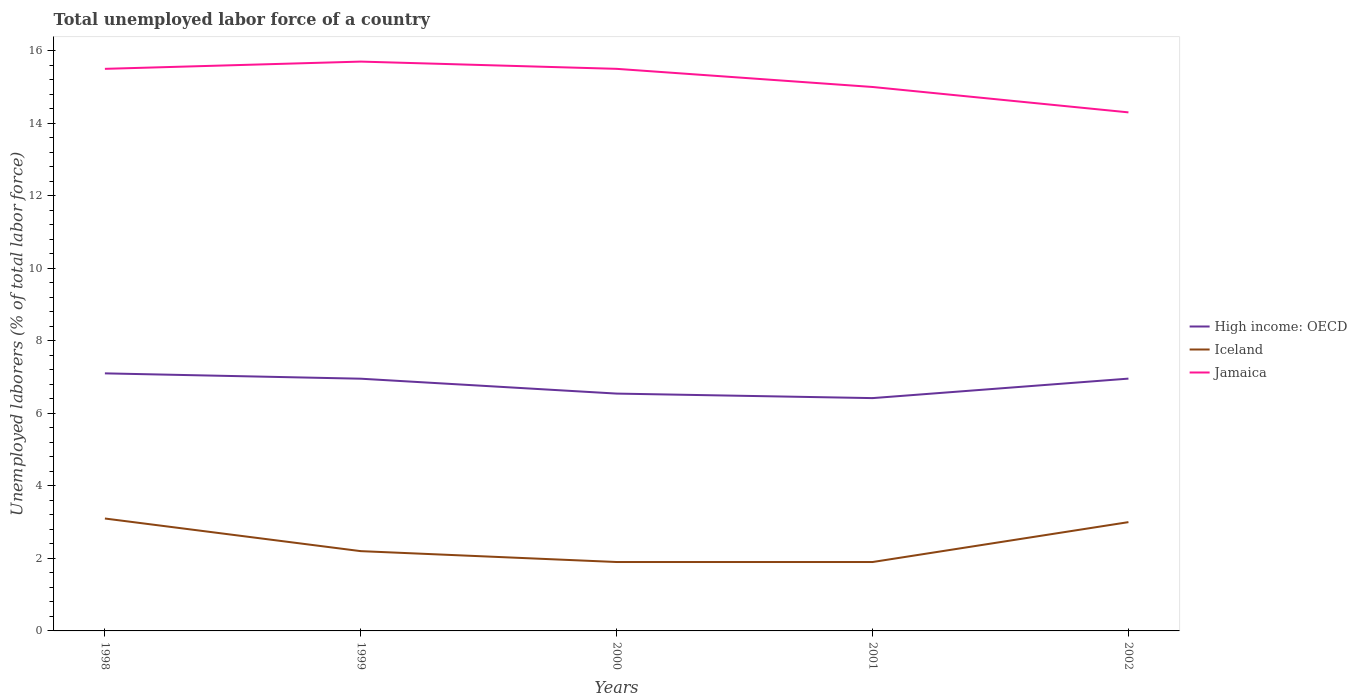Does the line corresponding to High income: OECD intersect with the line corresponding to Jamaica?
Provide a succinct answer. No. Across all years, what is the maximum total unemployed labor force in Iceland?
Give a very brief answer. 1.9. What is the total total unemployed labor force in High income: OECD in the graph?
Provide a succinct answer. -0. What is the difference between the highest and the second highest total unemployed labor force in Iceland?
Give a very brief answer. 1.2. How many lines are there?
Offer a very short reply. 3. What is the difference between two consecutive major ticks on the Y-axis?
Your answer should be compact. 2. Are the values on the major ticks of Y-axis written in scientific E-notation?
Your answer should be compact. No. Does the graph contain grids?
Provide a short and direct response. No. How many legend labels are there?
Give a very brief answer. 3. How are the legend labels stacked?
Offer a terse response. Vertical. What is the title of the graph?
Make the answer very short. Total unemployed labor force of a country. What is the label or title of the Y-axis?
Offer a very short reply. Unemployed laborers (% of total labor force). What is the Unemployed laborers (% of total labor force) in High income: OECD in 1998?
Make the answer very short. 7.1. What is the Unemployed laborers (% of total labor force) in Iceland in 1998?
Your answer should be very brief. 3.1. What is the Unemployed laborers (% of total labor force) of Jamaica in 1998?
Offer a terse response. 15.5. What is the Unemployed laborers (% of total labor force) of High income: OECD in 1999?
Keep it short and to the point. 6.96. What is the Unemployed laborers (% of total labor force) in Iceland in 1999?
Make the answer very short. 2.2. What is the Unemployed laborers (% of total labor force) in Jamaica in 1999?
Offer a terse response. 15.7. What is the Unemployed laborers (% of total labor force) of High income: OECD in 2000?
Your answer should be compact. 6.54. What is the Unemployed laborers (% of total labor force) in Iceland in 2000?
Make the answer very short. 1.9. What is the Unemployed laborers (% of total labor force) of High income: OECD in 2001?
Ensure brevity in your answer.  6.42. What is the Unemployed laborers (% of total labor force) in Iceland in 2001?
Make the answer very short. 1.9. What is the Unemployed laborers (% of total labor force) in Jamaica in 2001?
Keep it short and to the point. 15. What is the Unemployed laborers (% of total labor force) in High income: OECD in 2002?
Your answer should be compact. 6.96. What is the Unemployed laborers (% of total labor force) in Iceland in 2002?
Ensure brevity in your answer.  3. What is the Unemployed laborers (% of total labor force) in Jamaica in 2002?
Ensure brevity in your answer.  14.3. Across all years, what is the maximum Unemployed laborers (% of total labor force) of High income: OECD?
Offer a terse response. 7.1. Across all years, what is the maximum Unemployed laborers (% of total labor force) of Iceland?
Ensure brevity in your answer.  3.1. Across all years, what is the maximum Unemployed laborers (% of total labor force) in Jamaica?
Make the answer very short. 15.7. Across all years, what is the minimum Unemployed laborers (% of total labor force) in High income: OECD?
Keep it short and to the point. 6.42. Across all years, what is the minimum Unemployed laborers (% of total labor force) in Iceland?
Your answer should be very brief. 1.9. Across all years, what is the minimum Unemployed laborers (% of total labor force) in Jamaica?
Your answer should be compact. 14.3. What is the total Unemployed laborers (% of total labor force) of High income: OECD in the graph?
Keep it short and to the point. 33.98. What is the total Unemployed laborers (% of total labor force) in Iceland in the graph?
Offer a very short reply. 12.1. What is the total Unemployed laborers (% of total labor force) in Jamaica in the graph?
Your answer should be very brief. 76. What is the difference between the Unemployed laborers (% of total labor force) in High income: OECD in 1998 and that in 1999?
Your response must be concise. 0.15. What is the difference between the Unemployed laborers (% of total labor force) in Iceland in 1998 and that in 1999?
Your answer should be very brief. 0.9. What is the difference between the Unemployed laborers (% of total labor force) in Jamaica in 1998 and that in 1999?
Provide a succinct answer. -0.2. What is the difference between the Unemployed laborers (% of total labor force) of High income: OECD in 1998 and that in 2000?
Make the answer very short. 0.56. What is the difference between the Unemployed laborers (% of total labor force) in Jamaica in 1998 and that in 2000?
Give a very brief answer. 0. What is the difference between the Unemployed laborers (% of total labor force) in High income: OECD in 1998 and that in 2001?
Offer a terse response. 0.68. What is the difference between the Unemployed laborers (% of total labor force) in Iceland in 1998 and that in 2001?
Offer a terse response. 1.2. What is the difference between the Unemployed laborers (% of total labor force) of Jamaica in 1998 and that in 2001?
Give a very brief answer. 0.5. What is the difference between the Unemployed laborers (% of total labor force) of High income: OECD in 1998 and that in 2002?
Offer a terse response. 0.15. What is the difference between the Unemployed laborers (% of total labor force) in Iceland in 1998 and that in 2002?
Ensure brevity in your answer.  0.1. What is the difference between the Unemployed laborers (% of total labor force) in High income: OECD in 1999 and that in 2000?
Give a very brief answer. 0.41. What is the difference between the Unemployed laborers (% of total labor force) in High income: OECD in 1999 and that in 2001?
Make the answer very short. 0.54. What is the difference between the Unemployed laborers (% of total labor force) in Jamaica in 1999 and that in 2001?
Give a very brief answer. 0.7. What is the difference between the Unemployed laborers (% of total labor force) of High income: OECD in 1999 and that in 2002?
Provide a succinct answer. -0. What is the difference between the Unemployed laborers (% of total labor force) of Iceland in 1999 and that in 2002?
Provide a succinct answer. -0.8. What is the difference between the Unemployed laborers (% of total labor force) in Jamaica in 1999 and that in 2002?
Make the answer very short. 1.4. What is the difference between the Unemployed laborers (% of total labor force) of High income: OECD in 2000 and that in 2001?
Your answer should be very brief. 0.12. What is the difference between the Unemployed laborers (% of total labor force) in High income: OECD in 2000 and that in 2002?
Offer a terse response. -0.41. What is the difference between the Unemployed laborers (% of total labor force) of Iceland in 2000 and that in 2002?
Provide a succinct answer. -1.1. What is the difference between the Unemployed laborers (% of total labor force) of High income: OECD in 2001 and that in 2002?
Your answer should be compact. -0.54. What is the difference between the Unemployed laborers (% of total labor force) in Iceland in 2001 and that in 2002?
Your answer should be very brief. -1.1. What is the difference between the Unemployed laborers (% of total labor force) in Jamaica in 2001 and that in 2002?
Provide a succinct answer. 0.7. What is the difference between the Unemployed laborers (% of total labor force) of High income: OECD in 1998 and the Unemployed laborers (% of total labor force) of Iceland in 1999?
Ensure brevity in your answer.  4.9. What is the difference between the Unemployed laborers (% of total labor force) of High income: OECD in 1998 and the Unemployed laborers (% of total labor force) of Jamaica in 1999?
Offer a terse response. -8.6. What is the difference between the Unemployed laborers (% of total labor force) of Iceland in 1998 and the Unemployed laborers (% of total labor force) of Jamaica in 1999?
Your answer should be very brief. -12.6. What is the difference between the Unemployed laborers (% of total labor force) of High income: OECD in 1998 and the Unemployed laborers (% of total labor force) of Iceland in 2000?
Your answer should be compact. 5.2. What is the difference between the Unemployed laborers (% of total labor force) in High income: OECD in 1998 and the Unemployed laborers (% of total labor force) in Jamaica in 2000?
Make the answer very short. -8.4. What is the difference between the Unemployed laborers (% of total labor force) of Iceland in 1998 and the Unemployed laborers (% of total labor force) of Jamaica in 2000?
Give a very brief answer. -12.4. What is the difference between the Unemployed laborers (% of total labor force) in High income: OECD in 1998 and the Unemployed laborers (% of total labor force) in Iceland in 2001?
Provide a succinct answer. 5.2. What is the difference between the Unemployed laborers (% of total labor force) of High income: OECD in 1998 and the Unemployed laborers (% of total labor force) of Jamaica in 2001?
Ensure brevity in your answer.  -7.9. What is the difference between the Unemployed laborers (% of total labor force) of High income: OECD in 1998 and the Unemployed laborers (% of total labor force) of Iceland in 2002?
Your answer should be very brief. 4.1. What is the difference between the Unemployed laborers (% of total labor force) in High income: OECD in 1998 and the Unemployed laborers (% of total labor force) in Jamaica in 2002?
Your response must be concise. -7.2. What is the difference between the Unemployed laborers (% of total labor force) in High income: OECD in 1999 and the Unemployed laborers (% of total labor force) in Iceland in 2000?
Make the answer very short. 5.06. What is the difference between the Unemployed laborers (% of total labor force) of High income: OECD in 1999 and the Unemployed laborers (% of total labor force) of Jamaica in 2000?
Your answer should be very brief. -8.54. What is the difference between the Unemployed laborers (% of total labor force) in Iceland in 1999 and the Unemployed laborers (% of total labor force) in Jamaica in 2000?
Make the answer very short. -13.3. What is the difference between the Unemployed laborers (% of total labor force) of High income: OECD in 1999 and the Unemployed laborers (% of total labor force) of Iceland in 2001?
Offer a terse response. 5.06. What is the difference between the Unemployed laborers (% of total labor force) of High income: OECD in 1999 and the Unemployed laborers (% of total labor force) of Jamaica in 2001?
Your response must be concise. -8.04. What is the difference between the Unemployed laborers (% of total labor force) of High income: OECD in 1999 and the Unemployed laborers (% of total labor force) of Iceland in 2002?
Make the answer very short. 3.96. What is the difference between the Unemployed laborers (% of total labor force) of High income: OECD in 1999 and the Unemployed laborers (% of total labor force) of Jamaica in 2002?
Provide a short and direct response. -7.34. What is the difference between the Unemployed laborers (% of total labor force) of Iceland in 1999 and the Unemployed laborers (% of total labor force) of Jamaica in 2002?
Your answer should be very brief. -12.1. What is the difference between the Unemployed laborers (% of total labor force) in High income: OECD in 2000 and the Unemployed laborers (% of total labor force) in Iceland in 2001?
Your response must be concise. 4.64. What is the difference between the Unemployed laborers (% of total labor force) in High income: OECD in 2000 and the Unemployed laborers (% of total labor force) in Jamaica in 2001?
Offer a terse response. -8.46. What is the difference between the Unemployed laborers (% of total labor force) in Iceland in 2000 and the Unemployed laborers (% of total labor force) in Jamaica in 2001?
Ensure brevity in your answer.  -13.1. What is the difference between the Unemployed laborers (% of total labor force) of High income: OECD in 2000 and the Unemployed laborers (% of total labor force) of Iceland in 2002?
Your response must be concise. 3.54. What is the difference between the Unemployed laborers (% of total labor force) of High income: OECD in 2000 and the Unemployed laborers (% of total labor force) of Jamaica in 2002?
Make the answer very short. -7.76. What is the difference between the Unemployed laborers (% of total labor force) of High income: OECD in 2001 and the Unemployed laborers (% of total labor force) of Iceland in 2002?
Provide a short and direct response. 3.42. What is the difference between the Unemployed laborers (% of total labor force) in High income: OECD in 2001 and the Unemployed laborers (% of total labor force) in Jamaica in 2002?
Your answer should be compact. -7.88. What is the difference between the Unemployed laborers (% of total labor force) in Iceland in 2001 and the Unemployed laborers (% of total labor force) in Jamaica in 2002?
Give a very brief answer. -12.4. What is the average Unemployed laborers (% of total labor force) of High income: OECD per year?
Provide a succinct answer. 6.8. What is the average Unemployed laborers (% of total labor force) in Iceland per year?
Ensure brevity in your answer.  2.42. In the year 1998, what is the difference between the Unemployed laborers (% of total labor force) of High income: OECD and Unemployed laborers (% of total labor force) of Iceland?
Your answer should be compact. 4. In the year 1998, what is the difference between the Unemployed laborers (% of total labor force) in High income: OECD and Unemployed laborers (% of total labor force) in Jamaica?
Give a very brief answer. -8.4. In the year 1999, what is the difference between the Unemployed laborers (% of total labor force) in High income: OECD and Unemployed laborers (% of total labor force) in Iceland?
Your response must be concise. 4.76. In the year 1999, what is the difference between the Unemployed laborers (% of total labor force) of High income: OECD and Unemployed laborers (% of total labor force) of Jamaica?
Your response must be concise. -8.74. In the year 2000, what is the difference between the Unemployed laborers (% of total labor force) in High income: OECD and Unemployed laborers (% of total labor force) in Iceland?
Make the answer very short. 4.64. In the year 2000, what is the difference between the Unemployed laborers (% of total labor force) in High income: OECD and Unemployed laborers (% of total labor force) in Jamaica?
Provide a succinct answer. -8.96. In the year 2000, what is the difference between the Unemployed laborers (% of total labor force) in Iceland and Unemployed laborers (% of total labor force) in Jamaica?
Your answer should be compact. -13.6. In the year 2001, what is the difference between the Unemployed laborers (% of total labor force) of High income: OECD and Unemployed laborers (% of total labor force) of Iceland?
Your answer should be compact. 4.52. In the year 2001, what is the difference between the Unemployed laborers (% of total labor force) of High income: OECD and Unemployed laborers (% of total labor force) of Jamaica?
Provide a short and direct response. -8.58. In the year 2002, what is the difference between the Unemployed laborers (% of total labor force) of High income: OECD and Unemployed laborers (% of total labor force) of Iceland?
Offer a very short reply. 3.96. In the year 2002, what is the difference between the Unemployed laborers (% of total labor force) in High income: OECD and Unemployed laborers (% of total labor force) in Jamaica?
Your answer should be compact. -7.34. What is the ratio of the Unemployed laborers (% of total labor force) in High income: OECD in 1998 to that in 1999?
Provide a succinct answer. 1.02. What is the ratio of the Unemployed laborers (% of total labor force) of Iceland in 1998 to that in 1999?
Offer a very short reply. 1.41. What is the ratio of the Unemployed laborers (% of total labor force) in Jamaica in 1998 to that in 1999?
Make the answer very short. 0.99. What is the ratio of the Unemployed laborers (% of total labor force) of High income: OECD in 1998 to that in 2000?
Your answer should be very brief. 1.09. What is the ratio of the Unemployed laborers (% of total labor force) in Iceland in 1998 to that in 2000?
Ensure brevity in your answer.  1.63. What is the ratio of the Unemployed laborers (% of total labor force) in High income: OECD in 1998 to that in 2001?
Provide a short and direct response. 1.11. What is the ratio of the Unemployed laborers (% of total labor force) in Iceland in 1998 to that in 2001?
Give a very brief answer. 1.63. What is the ratio of the Unemployed laborers (% of total labor force) of Jamaica in 1998 to that in 2001?
Provide a succinct answer. 1.03. What is the ratio of the Unemployed laborers (% of total labor force) of High income: OECD in 1998 to that in 2002?
Your answer should be compact. 1.02. What is the ratio of the Unemployed laborers (% of total labor force) in Iceland in 1998 to that in 2002?
Make the answer very short. 1.03. What is the ratio of the Unemployed laborers (% of total labor force) of Jamaica in 1998 to that in 2002?
Your answer should be very brief. 1.08. What is the ratio of the Unemployed laborers (% of total labor force) of High income: OECD in 1999 to that in 2000?
Provide a succinct answer. 1.06. What is the ratio of the Unemployed laborers (% of total labor force) in Iceland in 1999 to that in 2000?
Offer a very short reply. 1.16. What is the ratio of the Unemployed laborers (% of total labor force) of Jamaica in 1999 to that in 2000?
Offer a terse response. 1.01. What is the ratio of the Unemployed laborers (% of total labor force) in High income: OECD in 1999 to that in 2001?
Provide a succinct answer. 1.08. What is the ratio of the Unemployed laborers (% of total labor force) in Iceland in 1999 to that in 2001?
Ensure brevity in your answer.  1.16. What is the ratio of the Unemployed laborers (% of total labor force) of Jamaica in 1999 to that in 2001?
Provide a short and direct response. 1.05. What is the ratio of the Unemployed laborers (% of total labor force) of High income: OECD in 1999 to that in 2002?
Ensure brevity in your answer.  1. What is the ratio of the Unemployed laborers (% of total labor force) in Iceland in 1999 to that in 2002?
Make the answer very short. 0.73. What is the ratio of the Unemployed laborers (% of total labor force) of Jamaica in 1999 to that in 2002?
Keep it short and to the point. 1.1. What is the ratio of the Unemployed laborers (% of total labor force) in High income: OECD in 2000 to that in 2001?
Provide a succinct answer. 1.02. What is the ratio of the Unemployed laborers (% of total labor force) in Iceland in 2000 to that in 2001?
Make the answer very short. 1. What is the ratio of the Unemployed laborers (% of total labor force) in High income: OECD in 2000 to that in 2002?
Offer a very short reply. 0.94. What is the ratio of the Unemployed laborers (% of total labor force) of Iceland in 2000 to that in 2002?
Give a very brief answer. 0.63. What is the ratio of the Unemployed laborers (% of total labor force) of Jamaica in 2000 to that in 2002?
Give a very brief answer. 1.08. What is the ratio of the Unemployed laborers (% of total labor force) in High income: OECD in 2001 to that in 2002?
Make the answer very short. 0.92. What is the ratio of the Unemployed laborers (% of total labor force) in Iceland in 2001 to that in 2002?
Provide a short and direct response. 0.63. What is the ratio of the Unemployed laborers (% of total labor force) of Jamaica in 2001 to that in 2002?
Offer a very short reply. 1.05. What is the difference between the highest and the second highest Unemployed laborers (% of total labor force) in High income: OECD?
Offer a terse response. 0.15. What is the difference between the highest and the lowest Unemployed laborers (% of total labor force) of High income: OECD?
Provide a succinct answer. 0.68. 